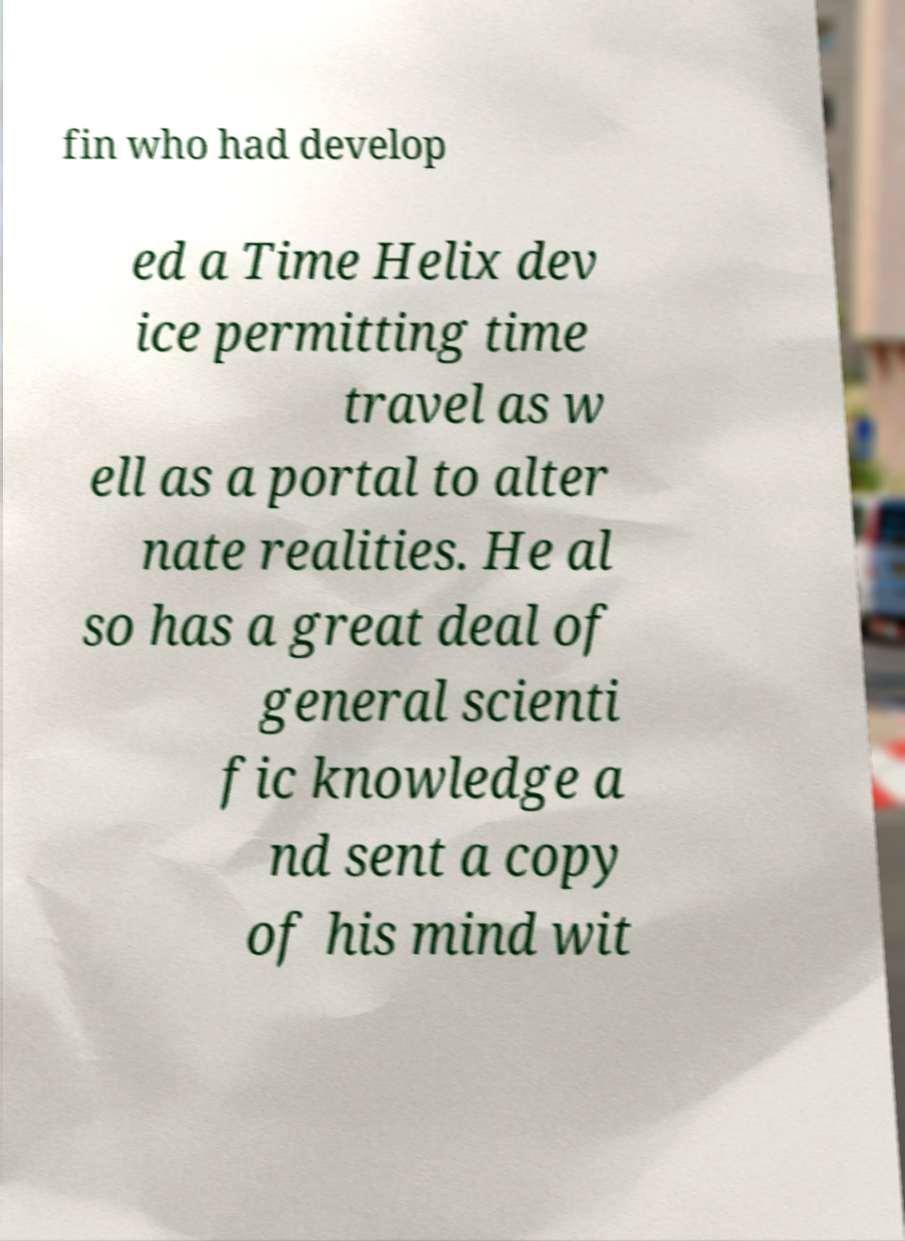Could you assist in decoding the text presented in this image and type it out clearly? fin who had develop ed a Time Helix dev ice permitting time travel as w ell as a portal to alter nate realities. He al so has a great deal of general scienti fic knowledge a nd sent a copy of his mind wit 